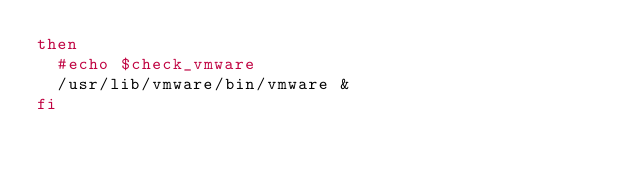Convert code to text. <code><loc_0><loc_0><loc_500><loc_500><_Bash_>then
	#echo $check_vmware
	/usr/lib/vmware/bin/vmware &
fi

</code> 